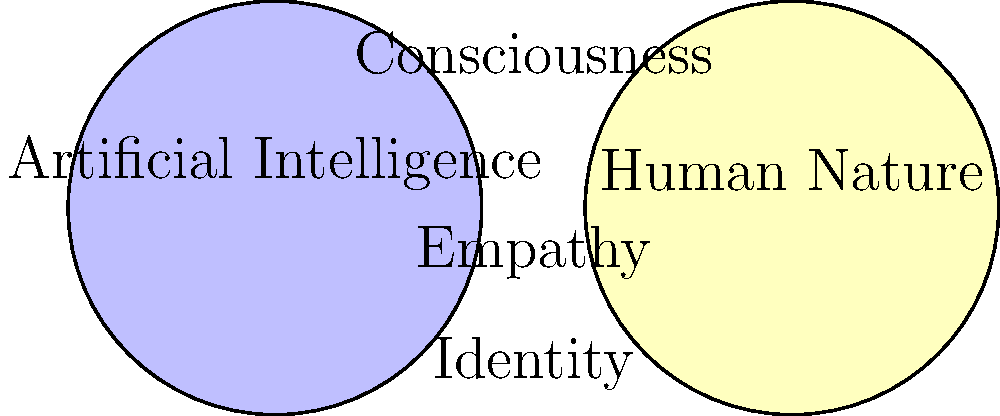In the Venn diagram representing themes in "Klara and the Sun," which concept is placed at the intersection of Artificial Intelligence and Human Nature, highlighting Ishiguro's exploration of the blurred lines between machine and human emotions? To answer this question, let's analyze the Venn diagram and its representation of themes in "Klara and the Sun":

1. The diagram consists of two overlapping circles, representing two major themes:
   - Left circle: Artificial Intelligence
   - Right circle: Human Nature

2. The overlapping area represents concepts that are common to both AI and human nature in the novel.

3. In this overlapping area, we can see the word "Empathy" placed centrally.

4. This placement is significant because:
   a) Empathy is a key theme in the novel, explored through Klara's (an AI) ability to understand and share human feelings.
   b) It challenges the traditional notion that empathy is exclusively a human trait.
   c) Ishiguro uses this concept to blur the lines between artificial and human emotions.

5. Other themes like "Identity" and "Consciousness" are also present in the diagram, but they are not specifically at the intersection of AI and Human Nature.

Therefore, the concept placed at the intersection of Artificial Intelligence and Human Nature, highlighting Ishiguro's exploration of the blurred lines between machine and human emotions, is Empathy.
Answer: Empathy 